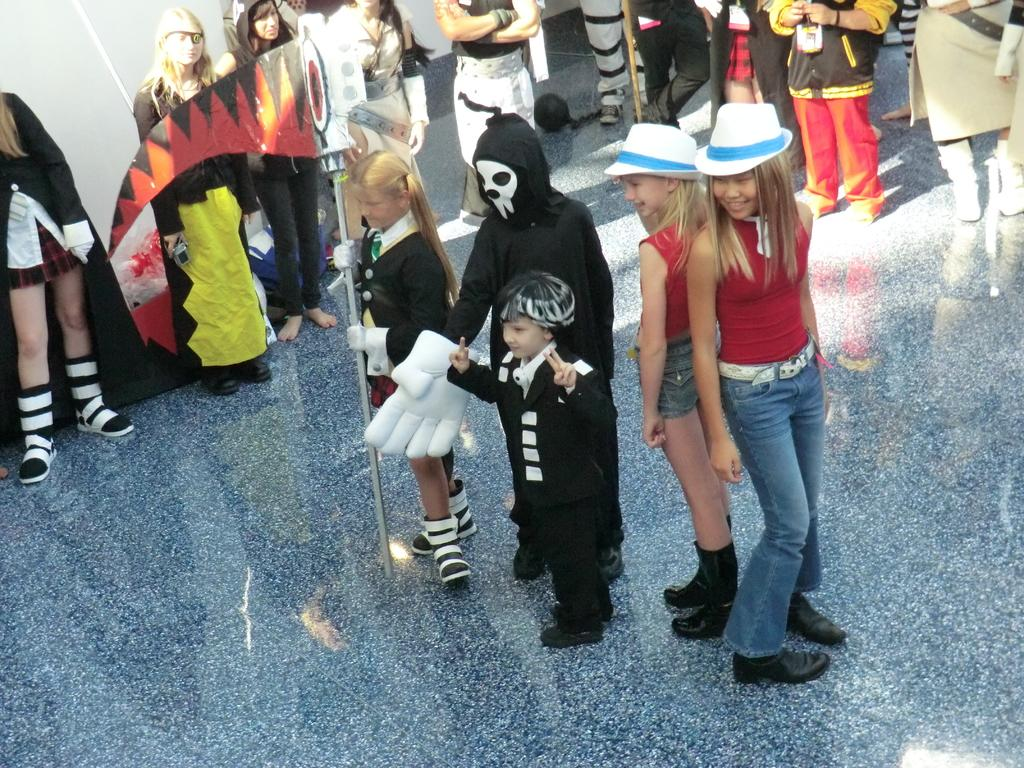Who or what can be seen in the image? There are people in the image. What are the people in the image doing? The people are standing. What are the people wearing in the image? The people are wearing costumes. What is the surface beneath the people in the image? There is a floor in the image. How many cups are being used by the people in the image? There is no mention of cups in the image; the people are wearing costumes and standing on a floor. 